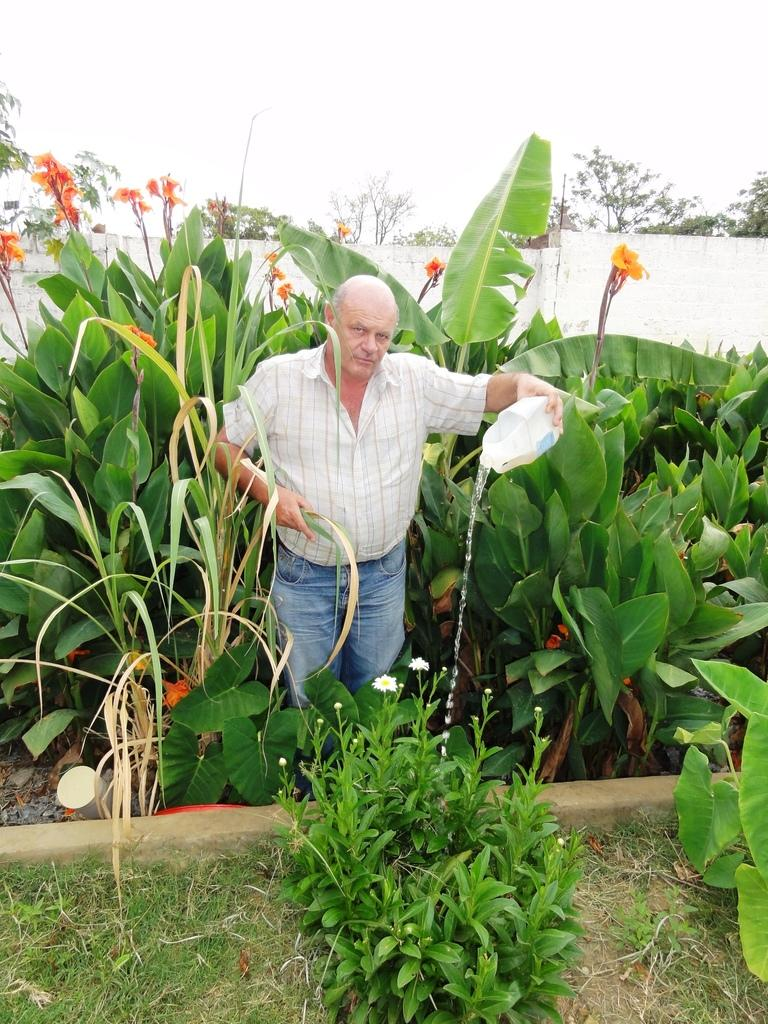What is the man in the image doing? The man is watering plants. What type of plants can be seen in the image? There are green plants visible in the image. What color is the marble in the image? There is no marble present in the image. Can you see an ant crawling on the man's shoulder in the image? There is no ant visible in the image. 